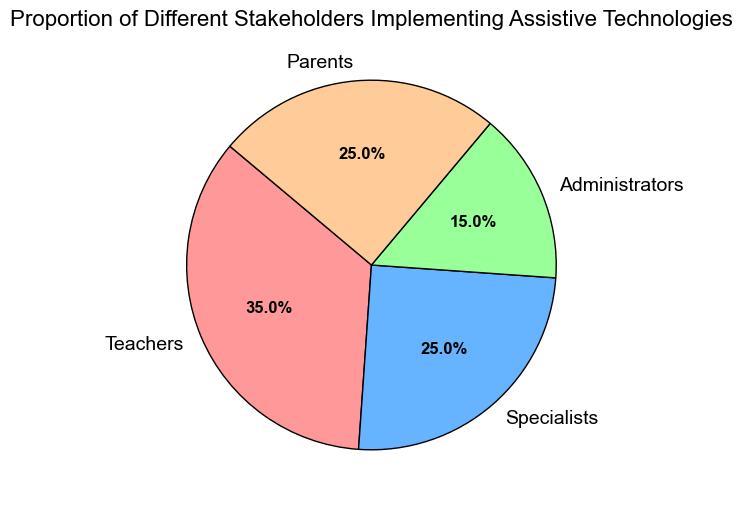Which stakeholder group is the largest? The size of the wedge for Teachers is the largest in the pie chart, indicating they have the highest proportion among all groups.
Answer: Teachers Which two stakeholder groups have the same proportion? The wedges for Specialists and Parents are equal in size, showing they both hold the same proportion of 25%.
Answer: Specialists and Parents What is the sum of the proportions of Specialists and Administrators? The proportion of Specialists is 25% and Administrators is 15%. Adding them together, 25% + 15% = 40%.
Answer: 40% What is the difference in proportion between Teachers and Administrators? Teachers have a proportion of 35%, and Administrators have 15%. The difference between them is 35% - 15% = 20%.
Answer: 20% Which stakeholder group's wedge is light blue in color? The pie chart shows that the light blue wedge corresponds to the Specialists group.
Answer: Specialists How much larger is the proportion of Teachers compared to Parents? The proportion of Teachers is 35%, and Parents are 25%. The difference is 35% - 25% = 10%.
Answer: 10% Which stakeholders together make up half of the total proportion? Specialists and Parents each have a proportion of 25%. When combined, they total 25% + 25% = 50%.
Answer: Specialists and Parents 